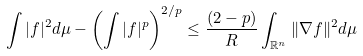Convert formula to latex. <formula><loc_0><loc_0><loc_500><loc_500>\int | f | ^ { 2 } d \mu - \left ( \int | f | ^ { p } \right ) ^ { 2 / p } \leq \frac { ( 2 - p ) } { R } \int _ { \mathbb { R } ^ { n } } \| \nabla f \| ^ { 2 } d \mu</formula> 